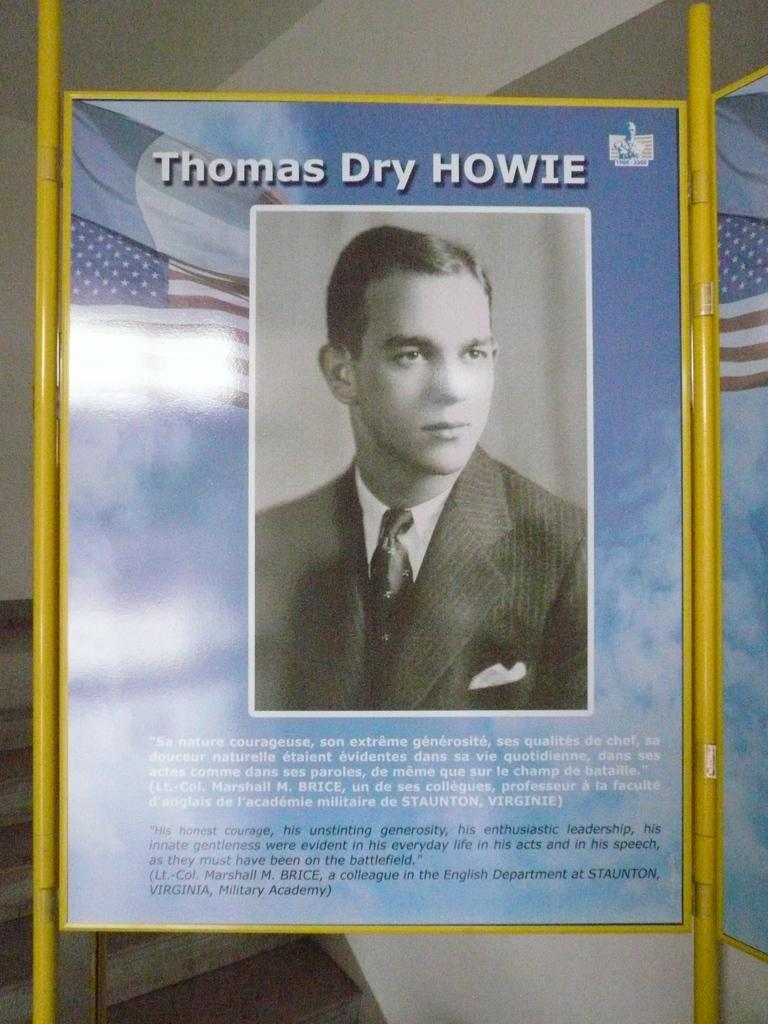<image>
Present a compact description of the photo's key features. A black and white picture of a man is held up with the words Thomas Dry HOWIE at the top. 